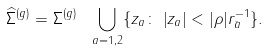Convert formula to latex. <formula><loc_0><loc_0><loc_500><loc_500>\widehat { \Sigma } ^ { ( g ) } = \Sigma ^ { ( g ) } \ \bigcup _ { a = 1 , 2 } \{ z _ { a } \colon \, \left | z _ { a } \right | < | \rho | r _ { \bar { a } } ^ { - 1 } \} .</formula> 